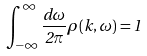Convert formula to latex. <formula><loc_0><loc_0><loc_500><loc_500>\int _ { - \infty } ^ { \infty } \frac { d \omega } { 2 \pi } \rho ( k , \omega ) = 1</formula> 